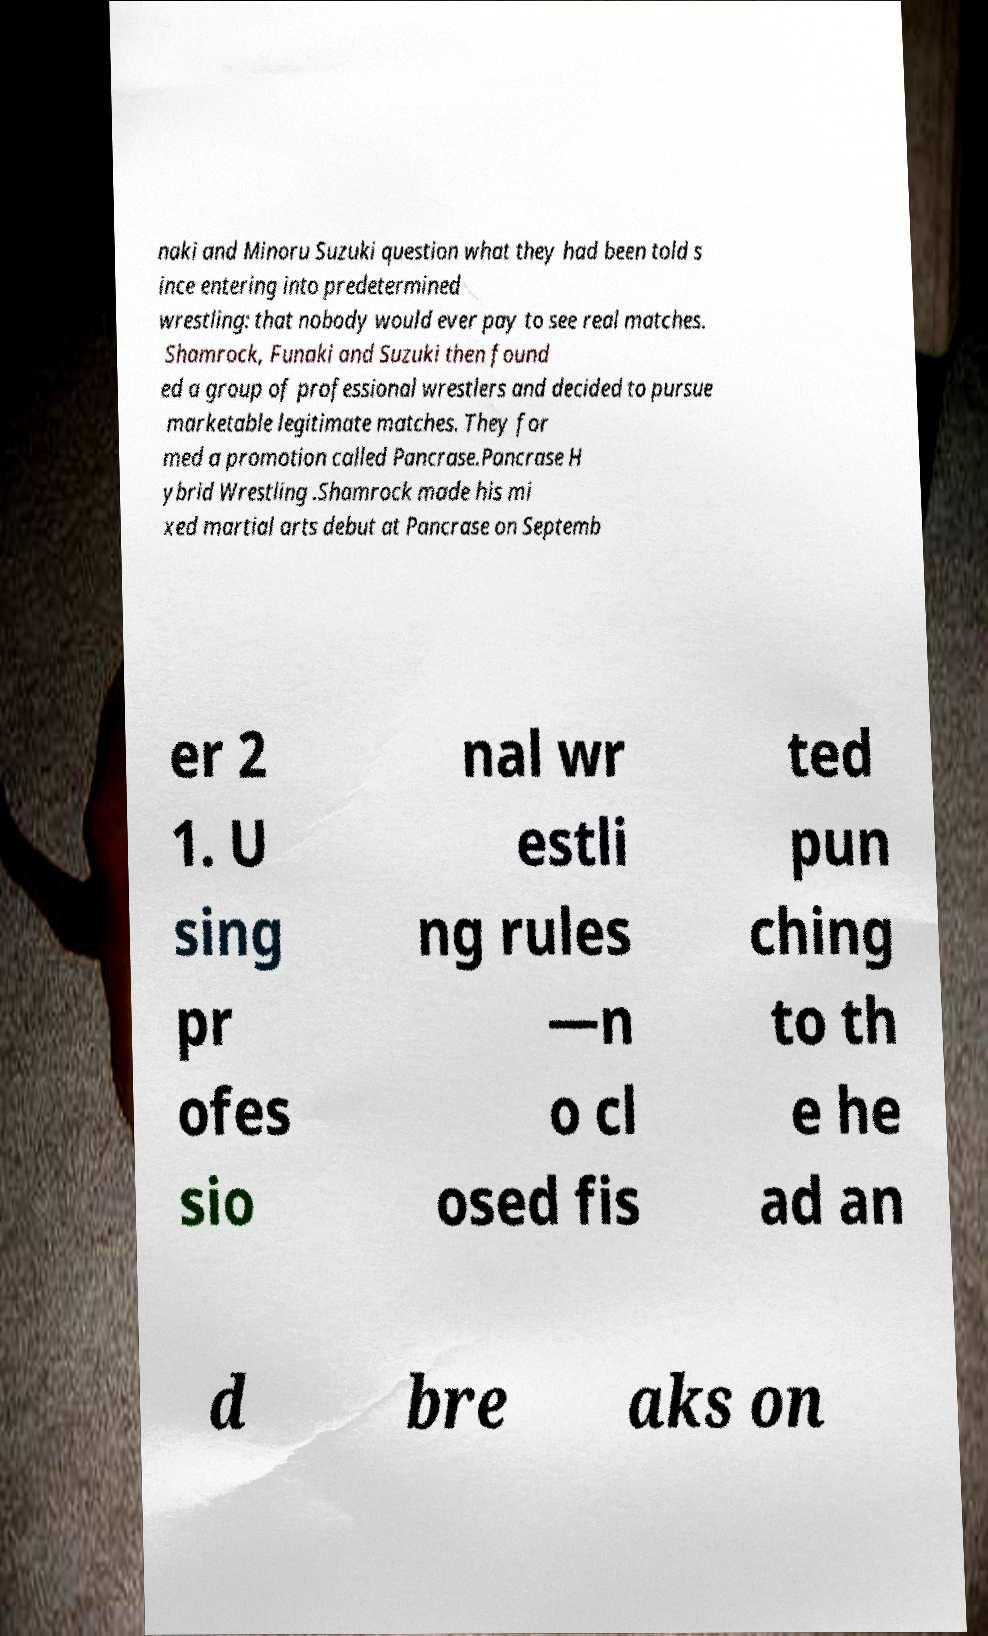There's text embedded in this image that I need extracted. Can you transcribe it verbatim? naki and Minoru Suzuki question what they had been told s ince entering into predetermined wrestling: that nobody would ever pay to see real matches. Shamrock, Funaki and Suzuki then found ed a group of professional wrestlers and decided to pursue marketable legitimate matches. They for med a promotion called Pancrase.Pancrase H ybrid Wrestling .Shamrock made his mi xed martial arts debut at Pancrase on Septemb er 2 1. U sing pr ofes sio nal wr estli ng rules —n o cl osed fis ted pun ching to th e he ad an d bre aks on 